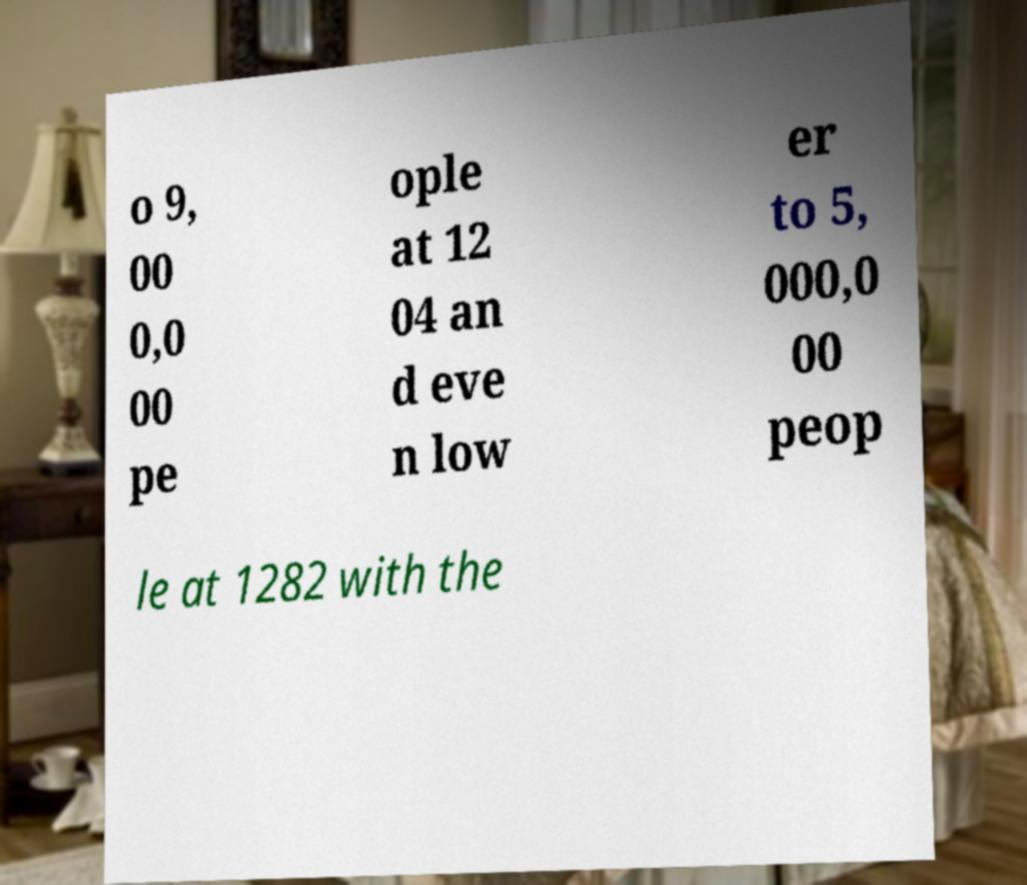Could you assist in decoding the text presented in this image and type it out clearly? o 9, 00 0,0 00 pe ople at 12 04 an d eve n low er to 5, 000,0 00 peop le at 1282 with the 